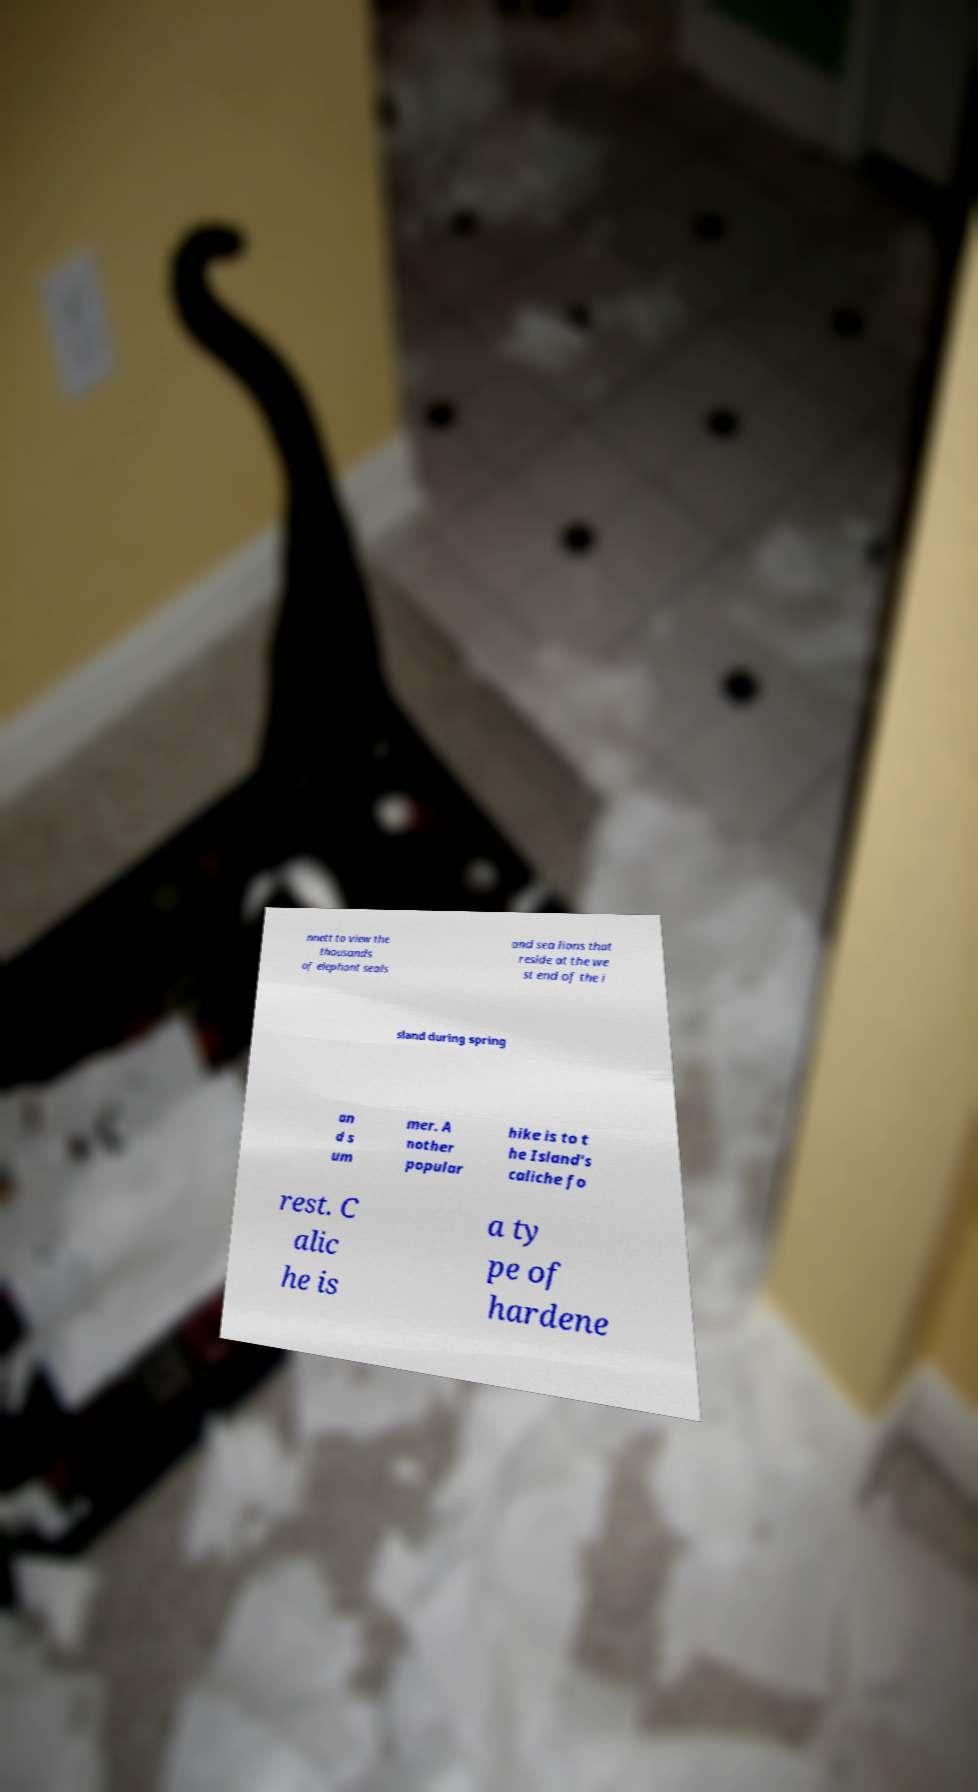What messages or text are displayed in this image? I need them in a readable, typed format. nnett to view the thousands of elephant seals and sea lions that reside at the we st end of the i sland during spring an d s um mer. A nother popular hike is to t he Island's caliche fo rest. C alic he is a ty pe of hardene 